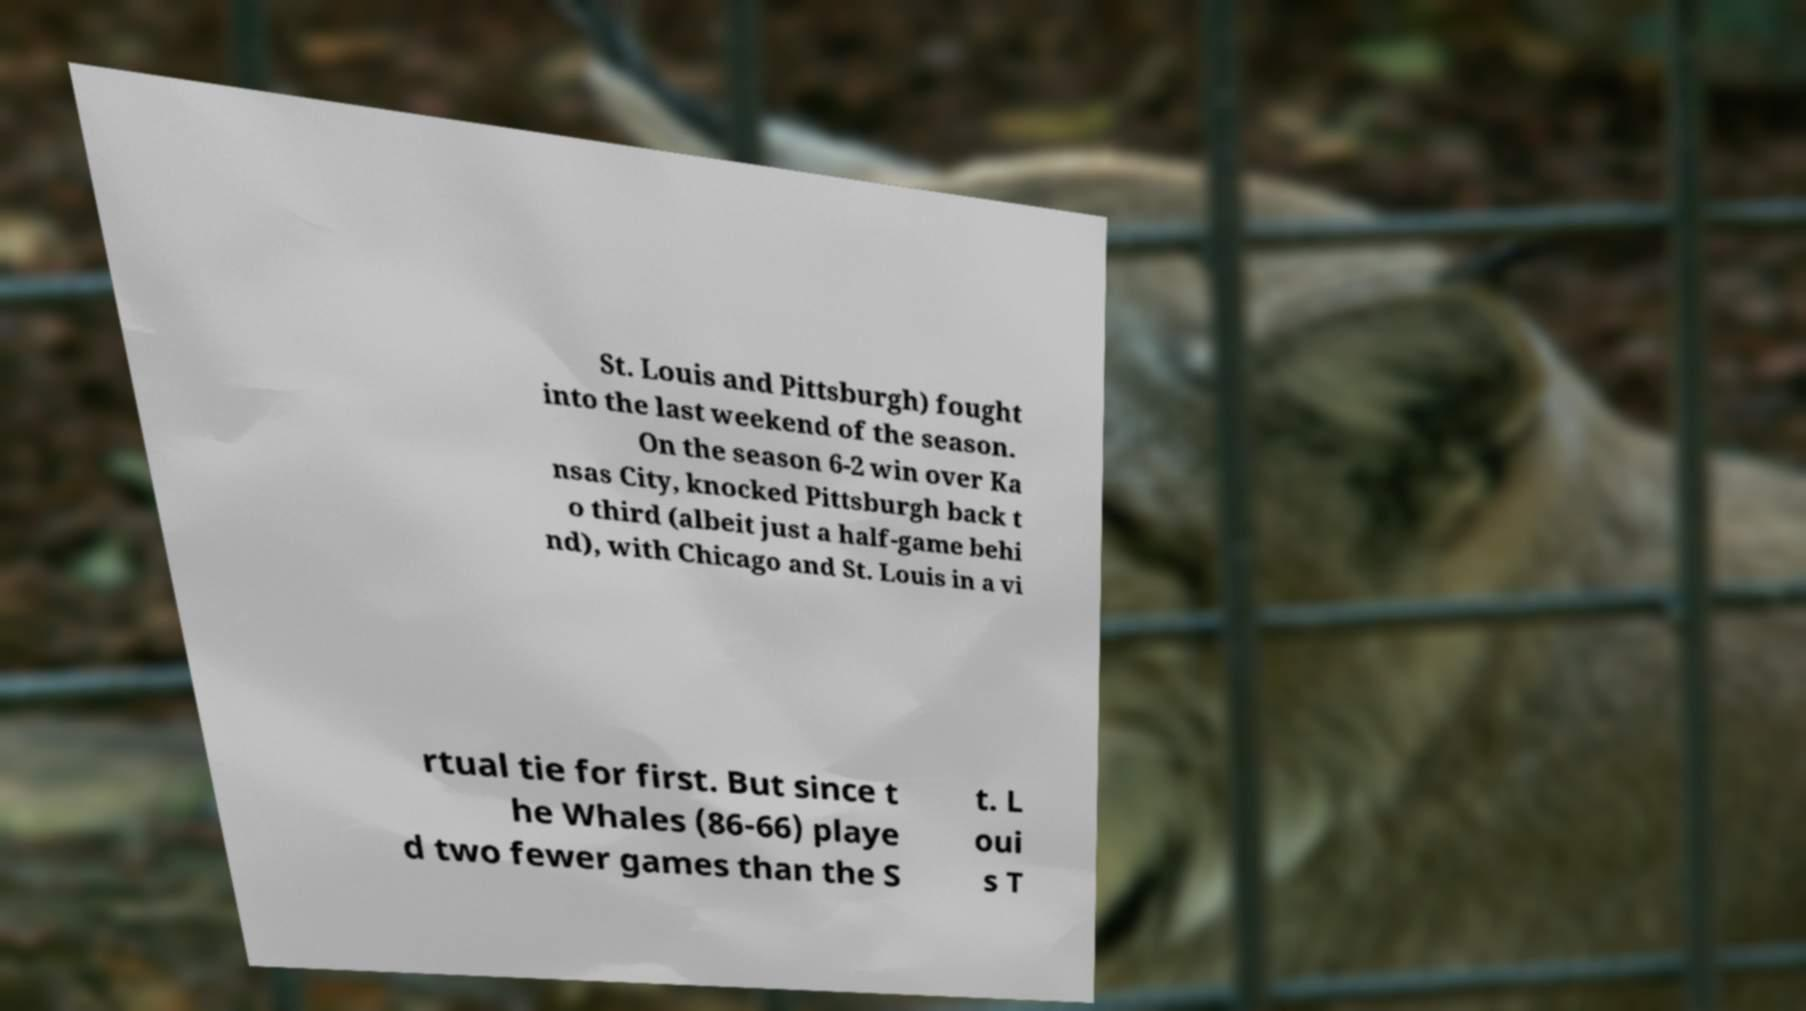Can you read and provide the text displayed in the image?This photo seems to have some interesting text. Can you extract and type it out for me? St. Louis and Pittsburgh) fought into the last weekend of the season. On the season 6-2 win over Ka nsas City, knocked Pittsburgh back t o third (albeit just a half-game behi nd), with Chicago and St. Louis in a vi rtual tie for first. But since t he Whales (86-66) playe d two fewer games than the S t. L oui s T 